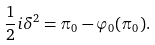<formula> <loc_0><loc_0><loc_500><loc_500>\frac { 1 } { 2 } i \delta ^ { 2 } = \pi _ { 0 } - \varphi _ { 0 } ( \pi _ { 0 } ) .</formula> 